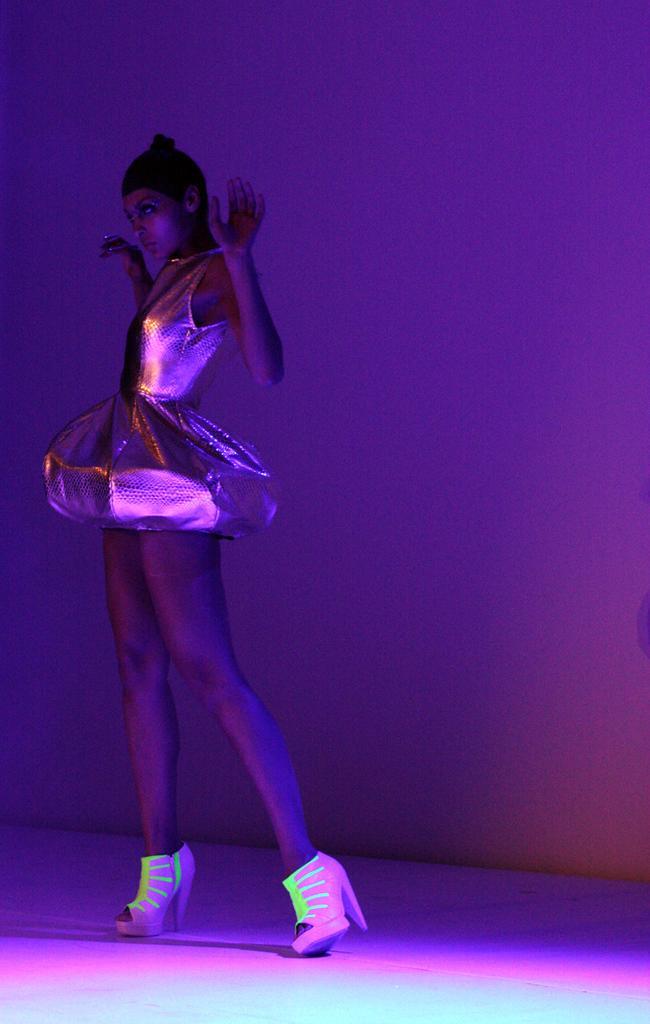How would you summarize this image in a sentence or two? In the foreground of this image, there is a woman standing in frock and shoes is on the surface. In the background, there is a pink and violet light on the wall. 